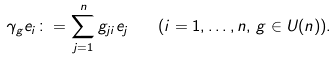<formula> <loc_0><loc_0><loc_500><loc_500>\gamma _ { g } e _ { i } \colon = \sum _ { j = 1 } ^ { n } g _ { j i } e _ { j } \quad ( i = 1 , \dots , n , \, g \in U ( n ) ) .</formula> 